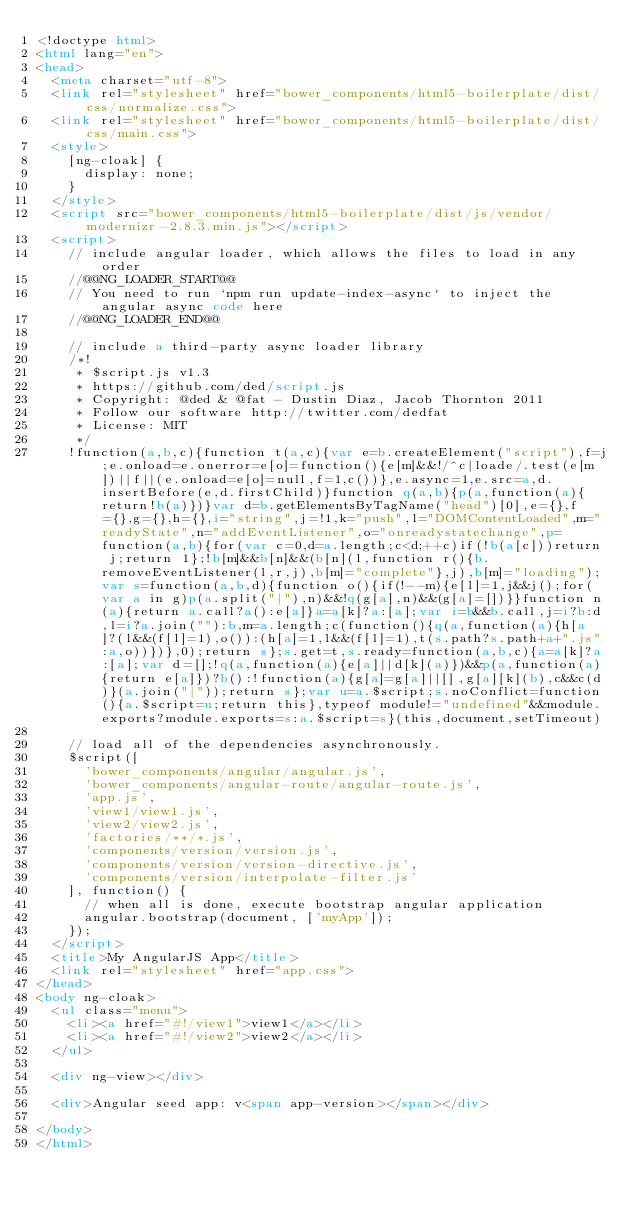<code> <loc_0><loc_0><loc_500><loc_500><_HTML_><!doctype html>
<html lang="en">
<head>
  <meta charset="utf-8">
  <link rel="stylesheet" href="bower_components/html5-boilerplate/dist/css/normalize.css">
  <link rel="stylesheet" href="bower_components/html5-boilerplate/dist/css/main.css">
  <style>
    [ng-cloak] {
      display: none;
    }
  </style>
  <script src="bower_components/html5-boilerplate/dist/js/vendor/modernizr-2.8.3.min.js"></script>
  <script>
    // include angular loader, which allows the files to load in any order
    //@@NG_LOADER_START@@
    // You need to run `npm run update-index-async` to inject the angular async code here
    //@@NG_LOADER_END@@

    // include a third-party async loader library
    /*!
     * $script.js v1.3
     * https://github.com/ded/script.js
     * Copyright: @ded & @fat - Dustin Diaz, Jacob Thornton 2011
     * Follow our software http://twitter.com/dedfat
     * License: MIT
     */
    !function(a,b,c){function t(a,c){var e=b.createElement("script"),f=j;e.onload=e.onerror=e[o]=function(){e[m]&&!/^c|loade/.test(e[m])||f||(e.onload=e[o]=null,f=1,c())},e.async=1,e.src=a,d.insertBefore(e,d.firstChild)}function q(a,b){p(a,function(a){return!b(a)})}var d=b.getElementsByTagName("head")[0],e={},f={},g={},h={},i="string",j=!1,k="push",l="DOMContentLoaded",m="readyState",n="addEventListener",o="onreadystatechange",p=function(a,b){for(var c=0,d=a.length;c<d;++c)if(!b(a[c]))return j;return 1};!b[m]&&b[n]&&(b[n](l,function r(){b.removeEventListener(l,r,j),b[m]="complete"},j),b[m]="loading");var s=function(a,b,d){function o(){if(!--m){e[l]=1,j&&j();for(var a in g)p(a.split("|"),n)&&!q(g[a],n)&&(g[a]=[])}}function n(a){return a.call?a():e[a]}a=a[k]?a:[a];var i=b&&b.call,j=i?b:d,l=i?a.join(""):b,m=a.length;c(function(){q(a,function(a){h[a]?(l&&(f[l]=1),o()):(h[a]=1,l&&(f[l]=1),t(s.path?s.path+a+".js":a,o))})},0);return s};s.get=t,s.ready=function(a,b,c){a=a[k]?a:[a];var d=[];!q(a,function(a){e[a]||d[k](a)})&&p(a,function(a){return e[a]})?b():!function(a){g[a]=g[a]||[],g[a][k](b),c&&c(d)}(a.join("|"));return s};var u=a.$script;s.noConflict=function(){a.$script=u;return this},typeof module!="undefined"&&module.exports?module.exports=s:a.$script=s}(this,document,setTimeout)

    // load all of the dependencies asynchronously.
    $script([
      'bower_components/angular/angular.js',
      'bower_components/angular-route/angular-route.js',
      'app.js',
      'view1/view1.js',
      'view2/view2.js',
      'factories/**/*.js',
      'components/version/version.js',
      'components/version/version-directive.js',
      'components/version/interpolate-filter.js'
    ], function() {
      // when all is done, execute bootstrap angular application
      angular.bootstrap(document, ['myApp']);
    });
  </script>
  <title>My AngularJS App</title>
  <link rel="stylesheet" href="app.css">
</head>
<body ng-cloak>
  <ul class="menu">
    <li><a href="#!/view1">view1</a></li>
    <li><a href="#!/view2">view2</a></li>
  </ul>

  <div ng-view></div>

  <div>Angular seed app: v<span app-version></span></div>

</body>
</html>
</code> 